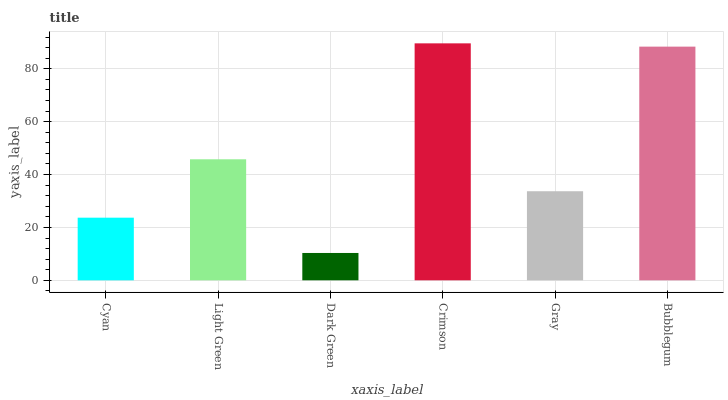Is Dark Green the minimum?
Answer yes or no. Yes. Is Crimson the maximum?
Answer yes or no. Yes. Is Light Green the minimum?
Answer yes or no. No. Is Light Green the maximum?
Answer yes or no. No. Is Light Green greater than Cyan?
Answer yes or no. Yes. Is Cyan less than Light Green?
Answer yes or no. Yes. Is Cyan greater than Light Green?
Answer yes or no. No. Is Light Green less than Cyan?
Answer yes or no. No. Is Light Green the high median?
Answer yes or no. Yes. Is Gray the low median?
Answer yes or no. Yes. Is Bubblegum the high median?
Answer yes or no. No. Is Cyan the low median?
Answer yes or no. No. 